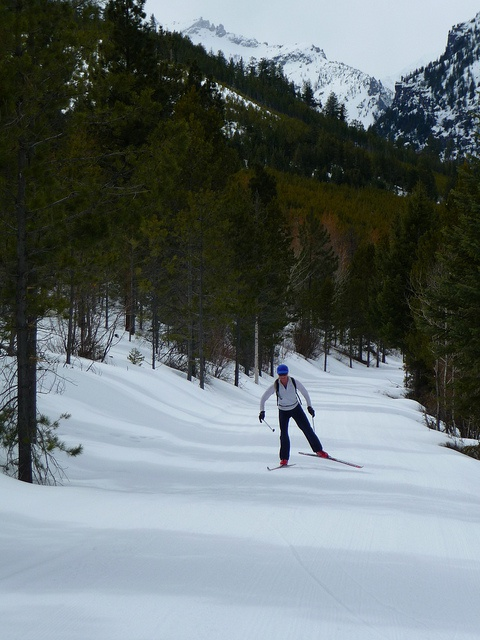Describe the objects in this image and their specific colors. I can see people in black, gray, and darkgray tones and skis in black, darkgray, and gray tones in this image. 